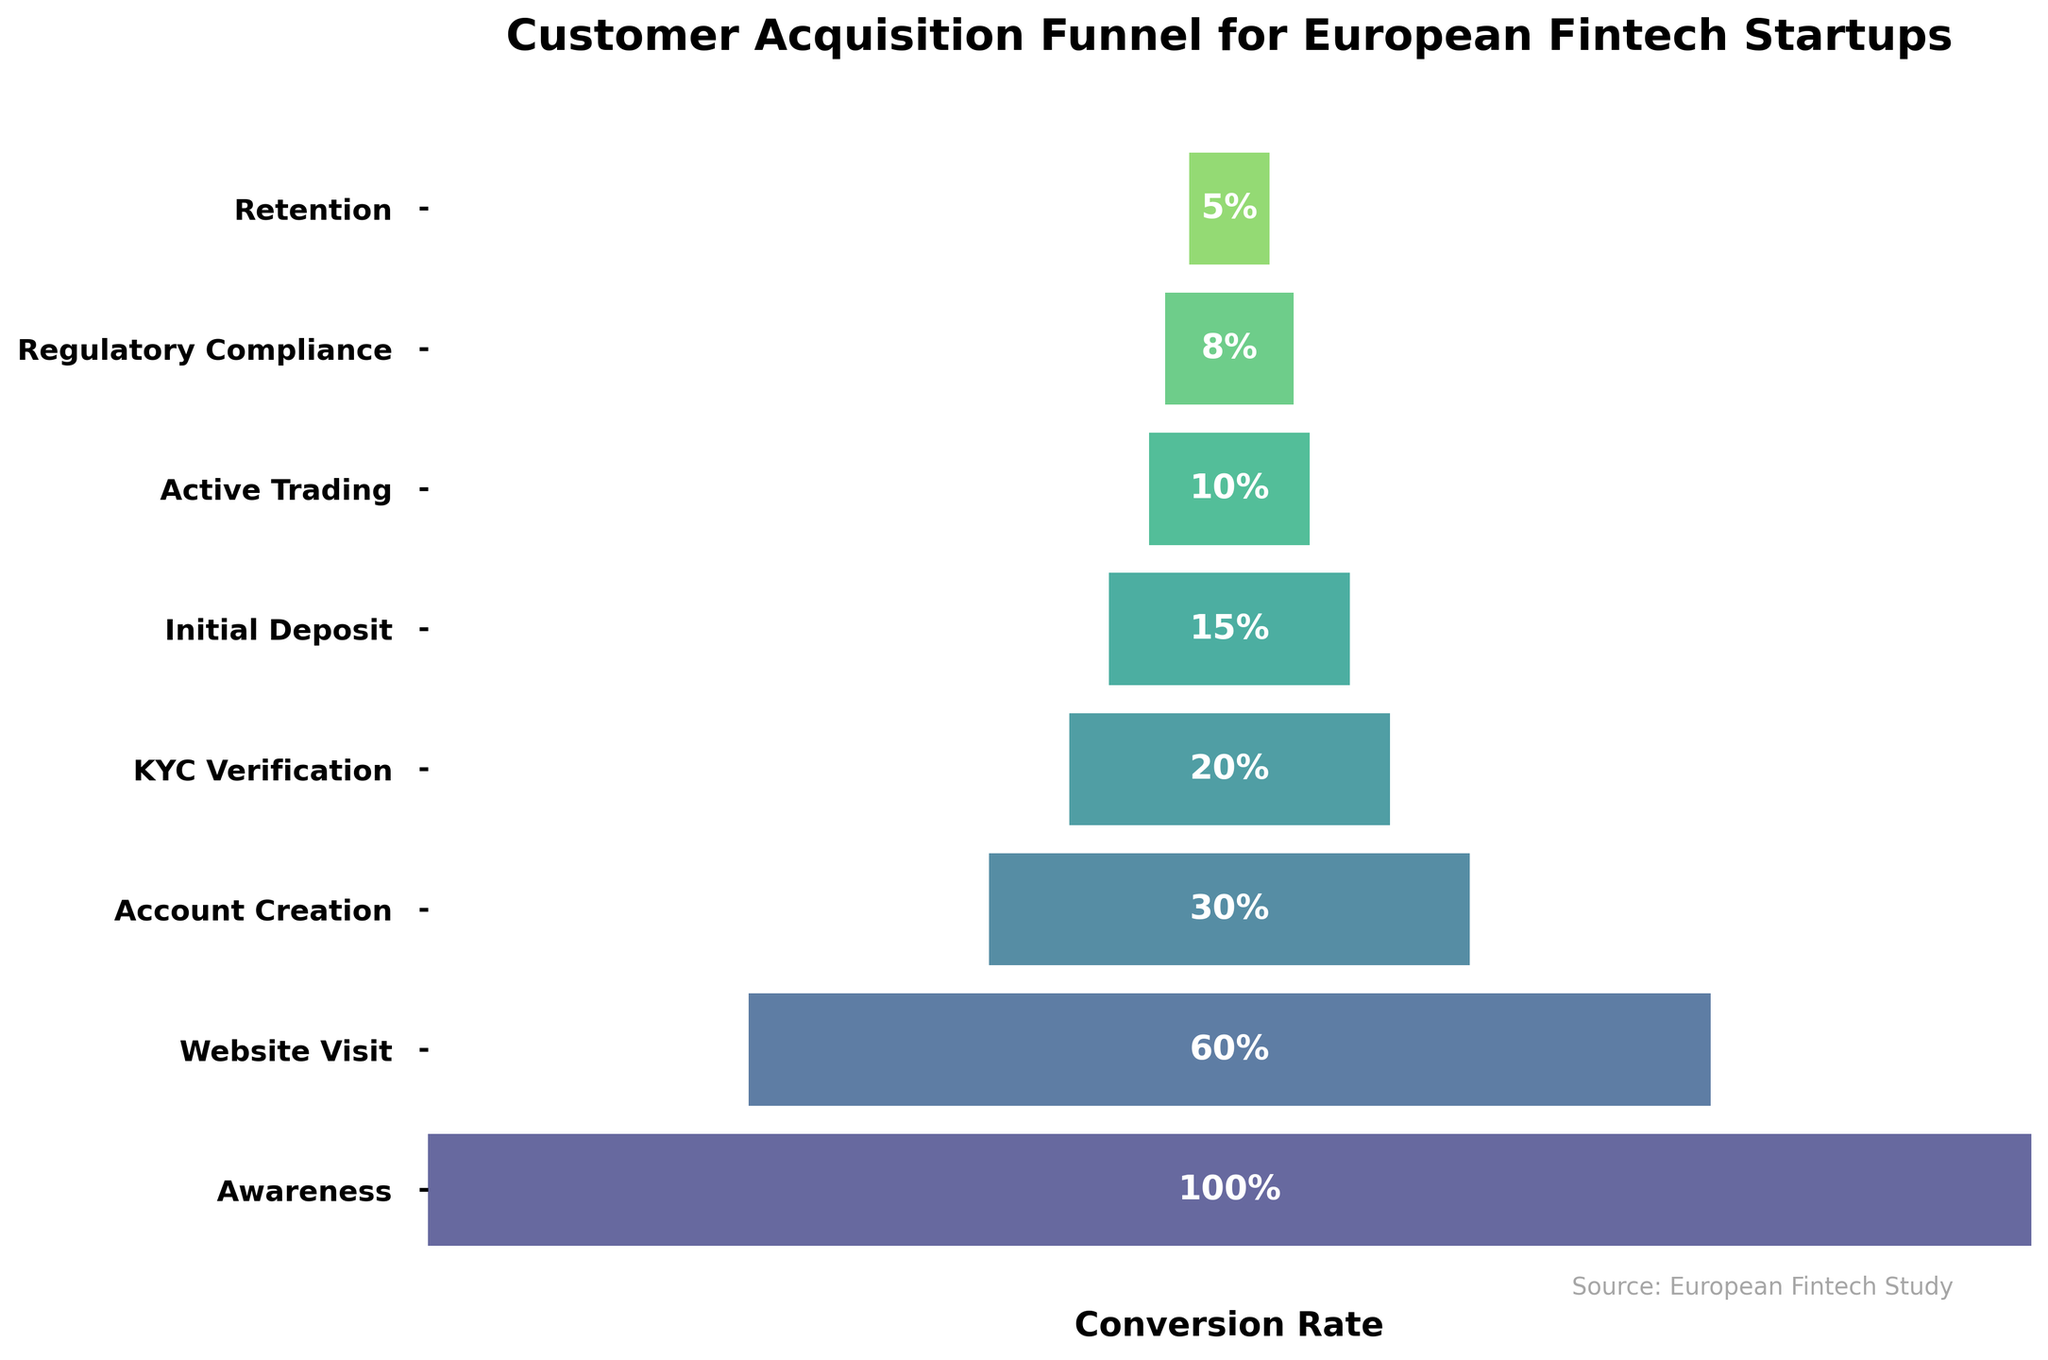What is the highest percentage in the funnel chart? The title "Customer Acquisition Funnel for European Fintech Startups" indicates the highest stage is "Awareness" which has a percentage of 100% shown at the top of the chart.
Answer: 100% What stage has the smallest percentage and what is that percentage? From the bottom of the chart, the smallest stage is "Retention" with a percentage of 5%.
Answer: Retention, 5% What is the title of the funnel chart? The title is located at the top-center of the chart above the funnel. It reads "Customer Acquisition Funnel for European Fintech Startups".
Answer: Customer Acquisition Funnel for European Fintech Startups How many stages are there in the customer acquisition process? The y-axis of the funnel chart lists all the stages. Counting them gives a total of 8 stages.
Answer: 8 What percentage of customers are retained after achieving regulatory compliance? The stages list "Regulatory Compliance" at 8% and "Retention" at 5%. The percentage retained after regulatory compliance is the "Retention" percentage.
Answer: 5% What percentage drop-off is there from website visit to account creation? Percentages are 60% for "Website Visit" and 30% for "Account Creation". Drop-off is calculated as 60% - 30% = 30%.
Answer: 30% What is the difference in percentage between initial deposit and active trading? Percentages for "Initial Deposit" and "Active Trading" are 15% and 10% respectively. The difference is 15% - 10% = 5%.
Answer: 5% Which stage has a higher percentage: KYC Verification or Initial Deposit? The percentage for "KYC Verification" is 20%, and for "Initial Deposit" it is 15%. 20% is higher than 15%.
Answer: KYC Verification What percentage of customers proceed from KYC Verification to Regulatory Compliance? KYC Verification is at 20% and Regulatory Compliance at 8%. The percentage proceeding is calculated as 8% / 20% * 100 = 40%.
Answer: 40% What percentage of customers visiting the website eventually start active trading? Website Visit is at 60% and Active Trading is at 10%. The percentage is calculated as 10% / 60% * 100 = 16.67%.
Answer: 16.67% 